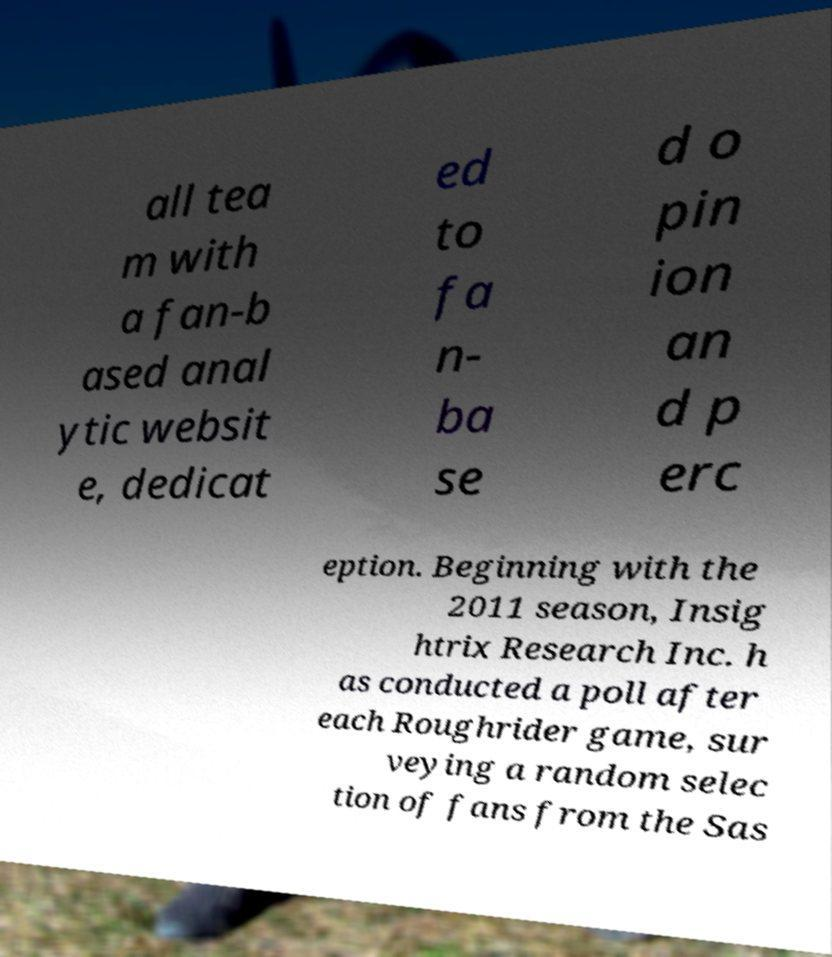Can you accurately transcribe the text from the provided image for me? all tea m with a fan-b ased anal ytic websit e, dedicat ed to fa n- ba se d o pin ion an d p erc eption. Beginning with the 2011 season, Insig htrix Research Inc. h as conducted a poll after each Roughrider game, sur veying a random selec tion of fans from the Sas 